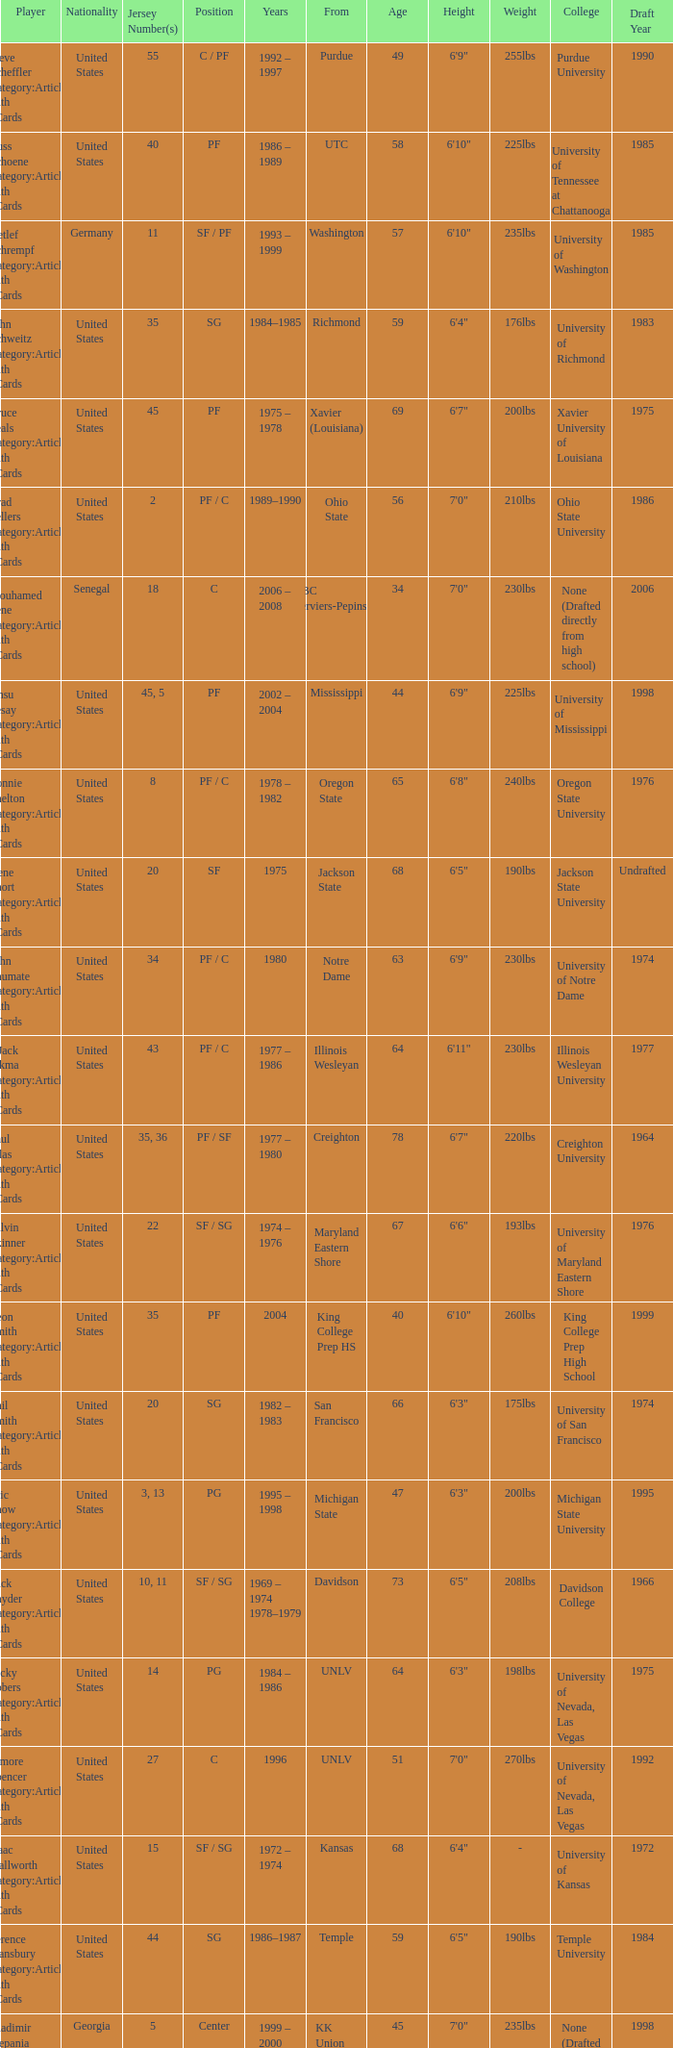Who sports the jersey number 20 and occupies the position of sg? Phil Smith Category:Articles with hCards, Jon Sundvold Category:Articles with hCards. 